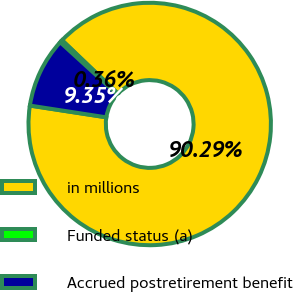Convert chart to OTSL. <chart><loc_0><loc_0><loc_500><loc_500><pie_chart><fcel>in millions<fcel>Funded status (a)<fcel>Accrued postretirement benefit<nl><fcel>90.29%<fcel>0.36%<fcel>9.35%<nl></chart> 